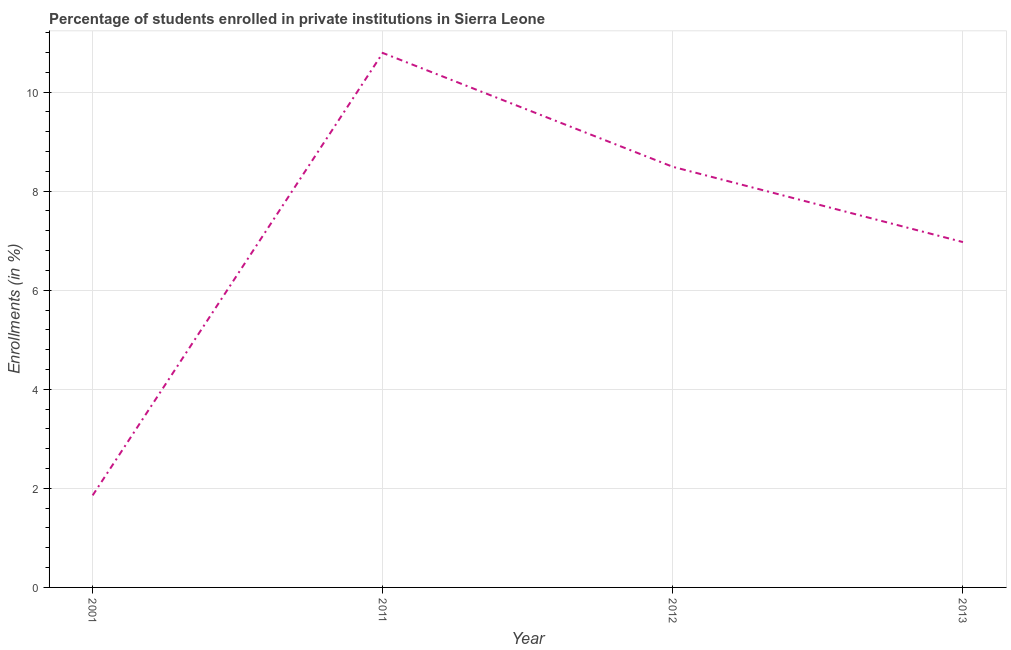What is the enrollments in private institutions in 2012?
Offer a very short reply. 8.49. Across all years, what is the maximum enrollments in private institutions?
Your answer should be very brief. 10.79. Across all years, what is the minimum enrollments in private institutions?
Keep it short and to the point. 1.86. In which year was the enrollments in private institutions minimum?
Offer a very short reply. 2001. What is the sum of the enrollments in private institutions?
Provide a short and direct response. 28.11. What is the difference between the enrollments in private institutions in 2012 and 2013?
Provide a short and direct response. 1.52. What is the average enrollments in private institutions per year?
Keep it short and to the point. 7.03. What is the median enrollments in private institutions?
Your answer should be very brief. 7.73. In how many years, is the enrollments in private institutions greater than 9.2 %?
Offer a very short reply. 1. What is the ratio of the enrollments in private institutions in 2001 to that in 2013?
Provide a short and direct response. 0.27. Is the enrollments in private institutions in 2001 less than that in 2013?
Your answer should be compact. Yes. Is the difference between the enrollments in private institutions in 2001 and 2012 greater than the difference between any two years?
Your response must be concise. No. What is the difference between the highest and the second highest enrollments in private institutions?
Ensure brevity in your answer.  2.3. What is the difference between the highest and the lowest enrollments in private institutions?
Make the answer very short. 8.93. In how many years, is the enrollments in private institutions greater than the average enrollments in private institutions taken over all years?
Give a very brief answer. 2. Does the enrollments in private institutions monotonically increase over the years?
Ensure brevity in your answer.  No. How many years are there in the graph?
Give a very brief answer. 4. What is the difference between two consecutive major ticks on the Y-axis?
Your response must be concise. 2. What is the title of the graph?
Make the answer very short. Percentage of students enrolled in private institutions in Sierra Leone. What is the label or title of the X-axis?
Your answer should be compact. Year. What is the label or title of the Y-axis?
Keep it short and to the point. Enrollments (in %). What is the Enrollments (in %) in 2001?
Your answer should be compact. 1.86. What is the Enrollments (in %) in 2011?
Keep it short and to the point. 10.79. What is the Enrollments (in %) of 2012?
Provide a succinct answer. 8.49. What is the Enrollments (in %) of 2013?
Ensure brevity in your answer.  6.97. What is the difference between the Enrollments (in %) in 2001 and 2011?
Keep it short and to the point. -8.93. What is the difference between the Enrollments (in %) in 2001 and 2012?
Provide a short and direct response. -6.63. What is the difference between the Enrollments (in %) in 2001 and 2013?
Keep it short and to the point. -5.11. What is the difference between the Enrollments (in %) in 2011 and 2012?
Make the answer very short. 2.3. What is the difference between the Enrollments (in %) in 2011 and 2013?
Offer a terse response. 3.82. What is the difference between the Enrollments (in %) in 2012 and 2013?
Keep it short and to the point. 1.52. What is the ratio of the Enrollments (in %) in 2001 to that in 2011?
Your answer should be very brief. 0.17. What is the ratio of the Enrollments (in %) in 2001 to that in 2012?
Ensure brevity in your answer.  0.22. What is the ratio of the Enrollments (in %) in 2001 to that in 2013?
Provide a short and direct response. 0.27. What is the ratio of the Enrollments (in %) in 2011 to that in 2012?
Provide a succinct answer. 1.27. What is the ratio of the Enrollments (in %) in 2011 to that in 2013?
Provide a succinct answer. 1.55. What is the ratio of the Enrollments (in %) in 2012 to that in 2013?
Make the answer very short. 1.22. 